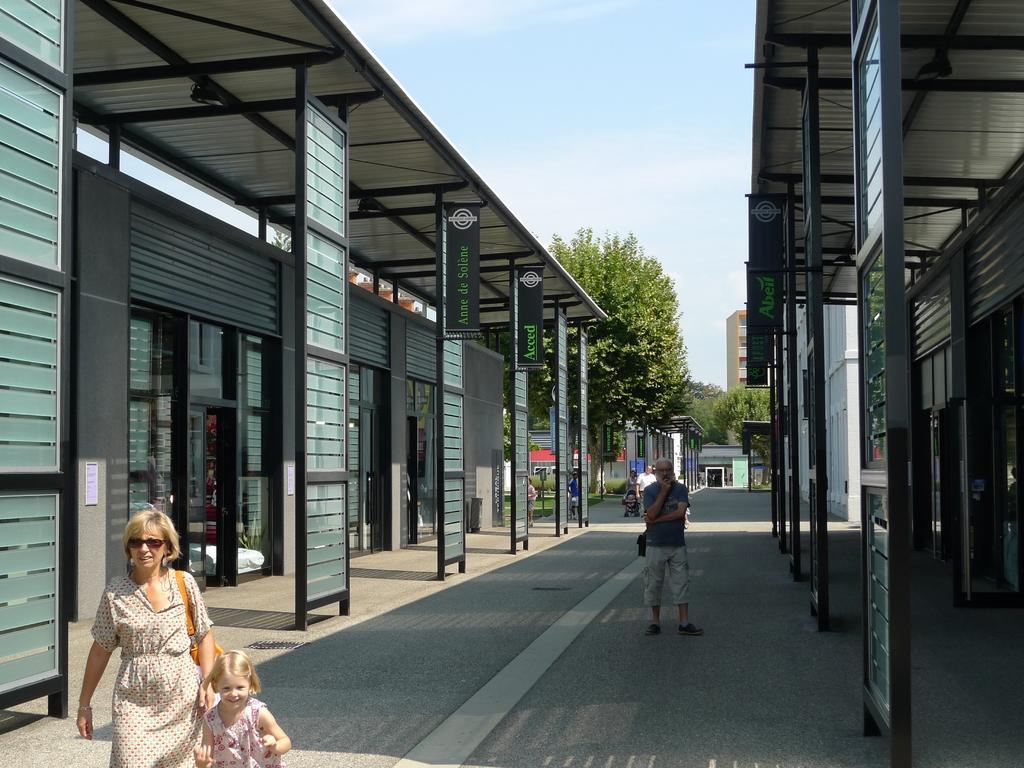How would you summarize this image in a sentence or two? In this image we can see persons on the road, shed, stores, information boards, name plates, trees and sky. 